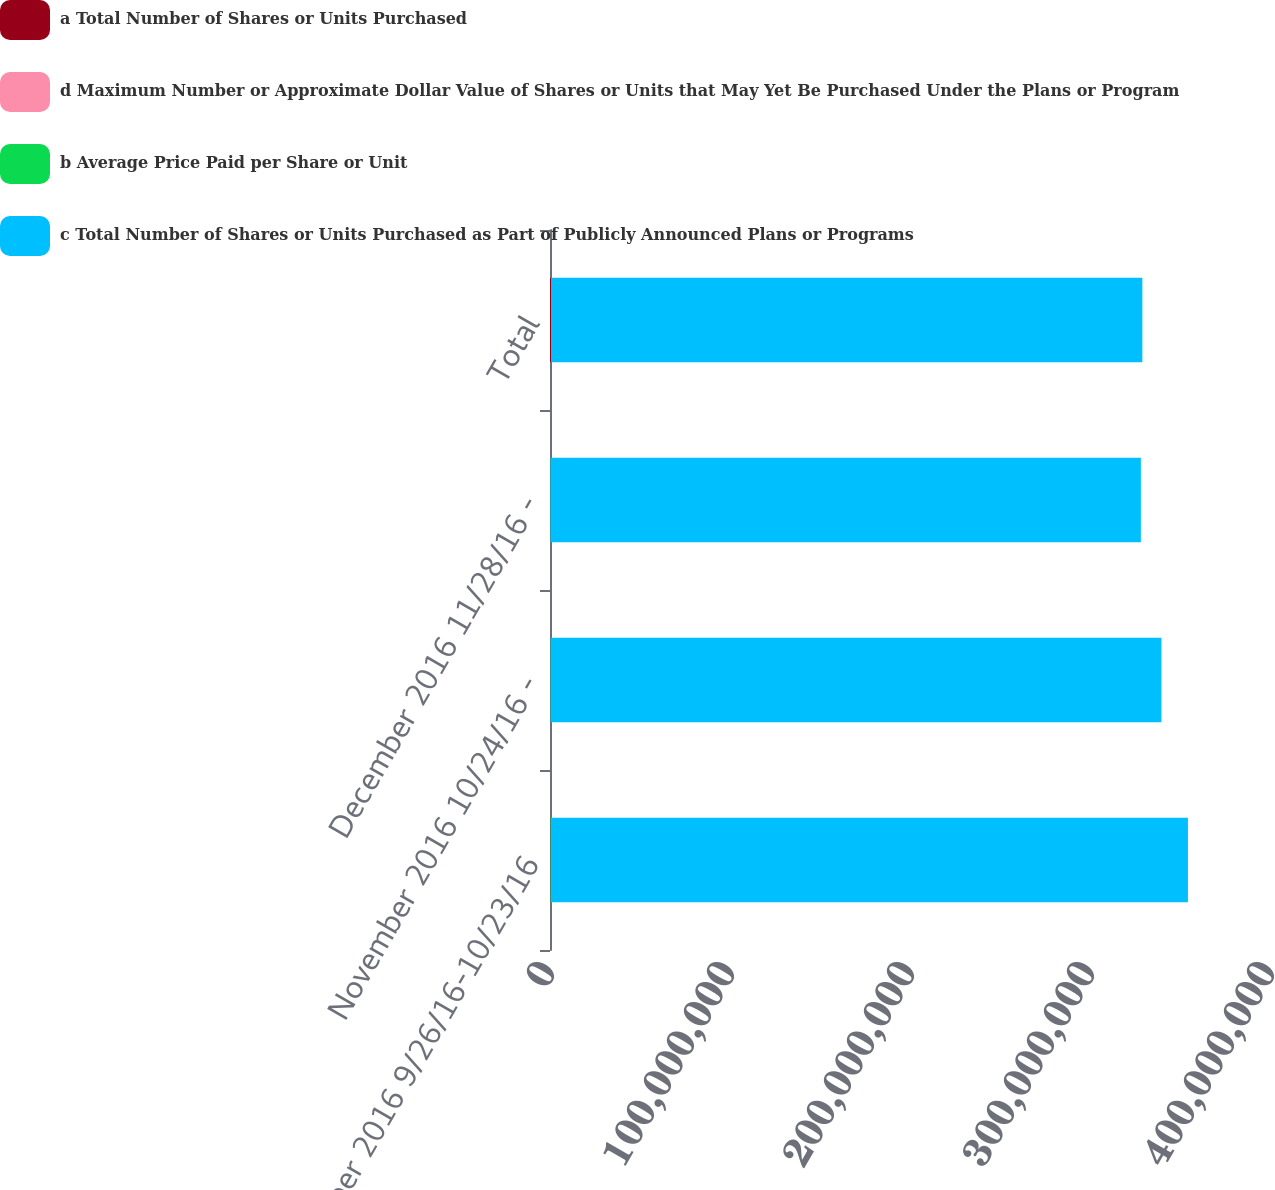Convert chart. <chart><loc_0><loc_0><loc_500><loc_500><stacked_bar_chart><ecel><fcel>October 2016 9/26/16-10/23/16<fcel>November 2016 10/24/16 -<fcel>December 2016 11/28/16 -<fcel>Total<nl><fcel>a Total Number of Shares or Units Purchased<fcel>240000<fcel>174000<fcel>136000<fcel>550000<nl><fcel>d Maximum Number or Approximate Dollar Value of Shares or Units that May Yet Be Purchased Under the Plans or Program<fcel>79.97<fcel>83.85<fcel>83.44<fcel>82.06<nl><fcel>b Average Price Paid per Share or Unit<fcel>240000<fcel>174000<fcel>136000<fcel>550000<nl><fcel>c Total Number of Shares or Units Purchased as Part of Publicly Announced Plans or Programs<fcel>3.53928e+08<fcel>3.39338e+08<fcel>3.2799e+08<fcel>3.2799e+08<nl></chart> 